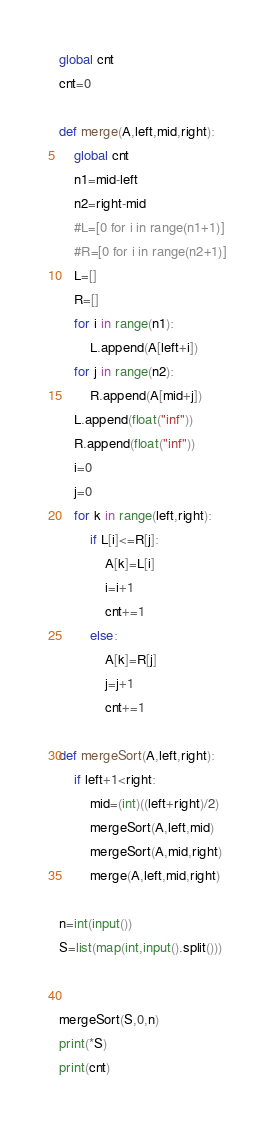Convert code to text. <code><loc_0><loc_0><loc_500><loc_500><_Python_>global cnt
cnt=0

def merge(A,left,mid,right):
    global cnt
    n1=mid-left
    n2=right-mid
    #L=[0 for i in range(n1+1)]
    #R=[0 for i in range(n2+1)]
    L=[]
    R=[]
    for i in range(n1):
        L.append(A[left+i])
    for j in range(n2):
        R.append(A[mid+j])
    L.append(float("inf"))
    R.append(float("inf"))
    i=0
    j=0
    for k in range(left,right):
        if L[i]<=R[j]:
            A[k]=L[i]
            i=i+1
            cnt+=1
        else:
            A[k]=R[j]
            j=j+1
            cnt+=1

def mergeSort(A,left,right):
    if left+1<right:
        mid=(int)((left+right)/2)
        mergeSort(A,left,mid)
        mergeSort(A,mid,right)
        merge(A,left,mid,right)

n=int(input())
S=list(map(int,input().split()))


mergeSort(S,0,n)
print(*S)
print(cnt)
</code> 